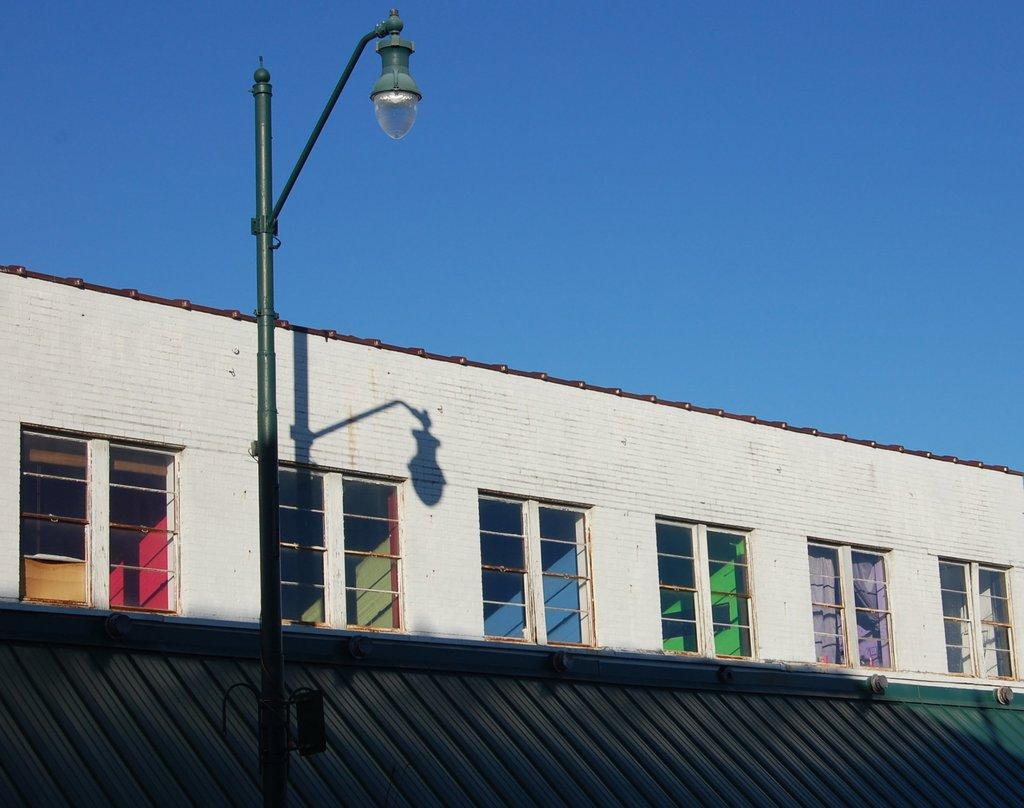What is located on the left side of the image? There is a pole with a light fixture on the left side of the image. What structure is in the middle of the image? There is a building in the middle of the image. What can be seen in the background of the image? The sky is visible in the background of the image. What type of leaf is falling from the sky in the image? There are no leaves present in the image; it features a pole with a light fixture, a building, and the sky. How is the sugar being used in the image? There is no sugar present in the image. 